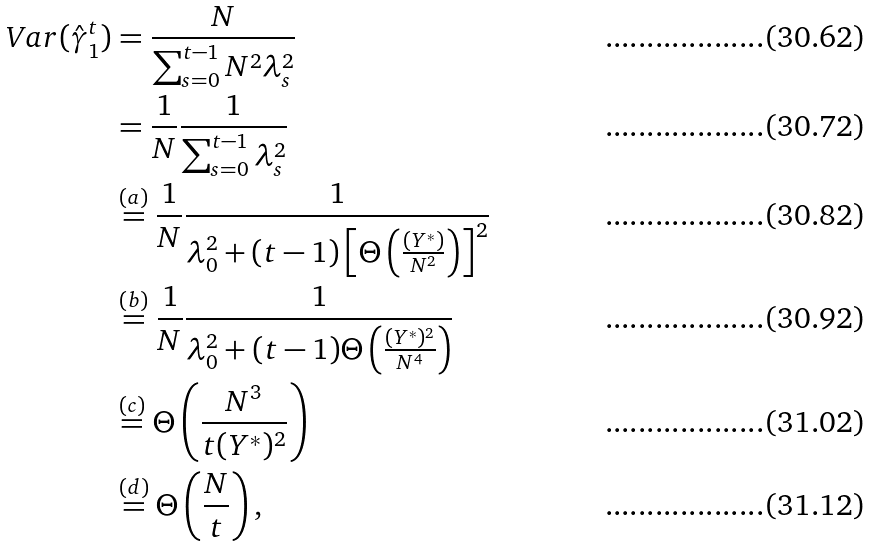<formula> <loc_0><loc_0><loc_500><loc_500>\ V a r ( \hat { \gamma } _ { 1 } ^ { t } ) & = \frac { N } { \sum _ { s = 0 } ^ { t - 1 } N ^ { 2 } \lambda _ { s } ^ { 2 } } \\ & = \frac { 1 } { N } \frac { 1 } { \sum _ { s = 0 } ^ { t - 1 } \lambda _ { s } ^ { 2 } } \\ & \overset { ( a ) } = \frac { 1 } { N } \frac { 1 } { \lambda _ { 0 } ^ { 2 } + ( t - 1 ) \left [ \Theta \left ( \frac { ( Y ^ { * } ) } { N ^ { 2 } } \right ) \right ] ^ { 2 } } \\ & \overset { ( b ) } = \frac { 1 } { N } \frac { 1 } { \lambda _ { 0 } ^ { 2 } + ( t - 1 ) \Theta \left ( \frac { ( Y ^ { * } ) ^ { 2 } } { N ^ { 4 } } \right ) } \\ & \overset { ( c ) } = \Theta \left ( \frac { N ^ { 3 } } { t ( Y ^ { * } ) ^ { 2 } } \right ) \\ & \overset { ( d ) } = \Theta \left ( \frac { N } { t } \right ) ,</formula> 